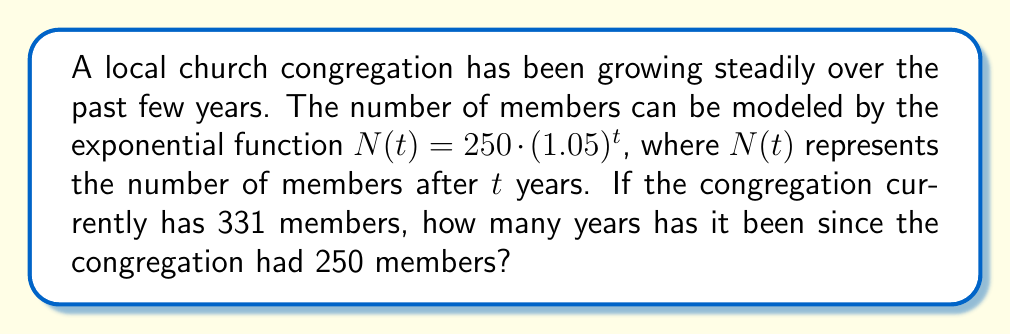Can you answer this question? Let's approach this step-by-step:

1) We're given the exponential function $N(t) = 250 \cdot (1.05)^t$

2) We know that currently, the congregation has 331 members. Let's substitute this into our equation:

   $331 = 250 \cdot (1.05)^t$

3) To solve for $t$, we first divide both sides by 250:

   $\frac{331}{250} = (1.05)^t$

4) Taking the natural logarithm of both sides:

   $\ln(\frac{331}{250}) = \ln((1.05)^t)$

5) Using the logarithm property $\ln(a^b) = b\ln(a)$:

   $\ln(\frac{331}{250}) = t \cdot \ln(1.05)$

6) Now we can solve for $t$:

   $t = \frac{\ln(\frac{331}{250})}{\ln(1.05)}$

7) Using a calculator:

   $t \approx 5.67$ years

8) Since we're dealing with whole years, we round up to 6 years.
Answer: 6 years 